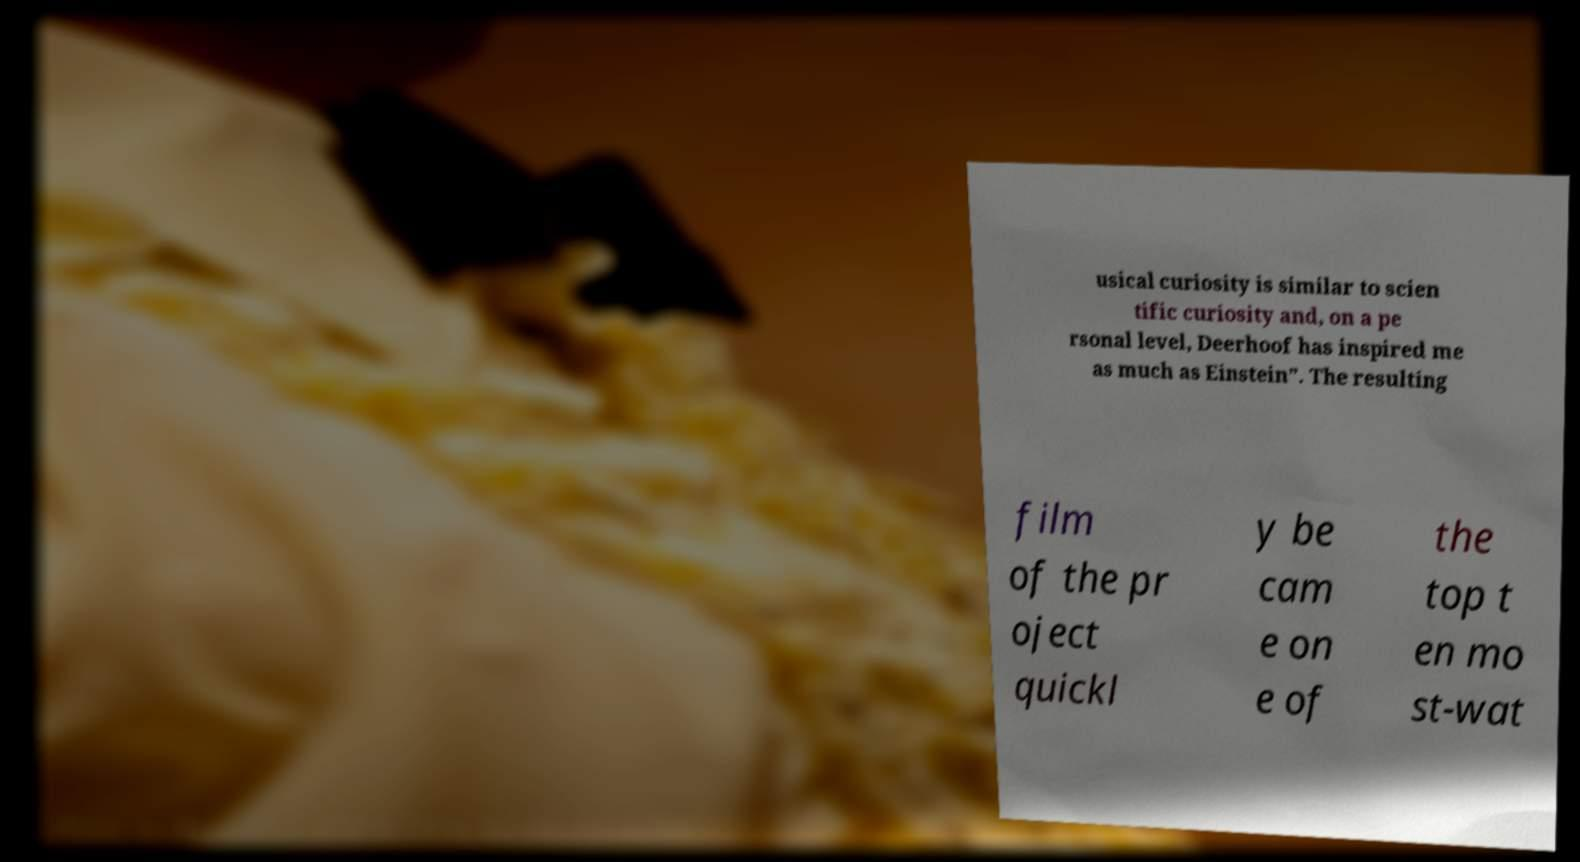Could you assist in decoding the text presented in this image and type it out clearly? usical curiosity is similar to scien tific curiosity and, on a pe rsonal level, Deerhoof has inspired me as much as Einstein”. The resulting film of the pr oject quickl y be cam e on e of the top t en mo st-wat 